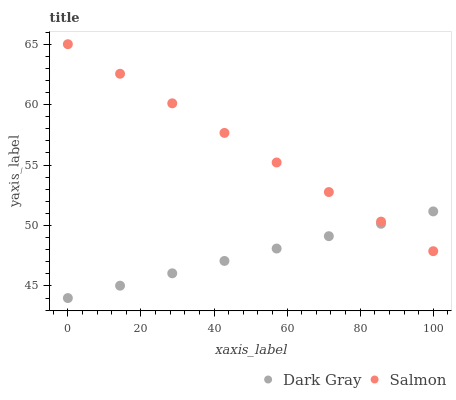Does Dark Gray have the minimum area under the curve?
Answer yes or no. Yes. Does Salmon have the maximum area under the curve?
Answer yes or no. Yes. Does Salmon have the minimum area under the curve?
Answer yes or no. No. Is Dark Gray the smoothest?
Answer yes or no. Yes. Is Salmon the roughest?
Answer yes or no. Yes. Is Salmon the smoothest?
Answer yes or no. No. Does Dark Gray have the lowest value?
Answer yes or no. Yes. Does Salmon have the lowest value?
Answer yes or no. No. Does Salmon have the highest value?
Answer yes or no. Yes. Does Dark Gray intersect Salmon?
Answer yes or no. Yes. Is Dark Gray less than Salmon?
Answer yes or no. No. Is Dark Gray greater than Salmon?
Answer yes or no. No. 